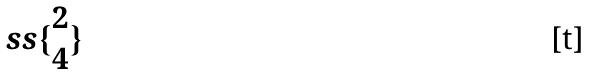<formula> <loc_0><loc_0><loc_500><loc_500>s s \{ \begin{matrix} 2 \\ 4 \end{matrix} \}</formula> 